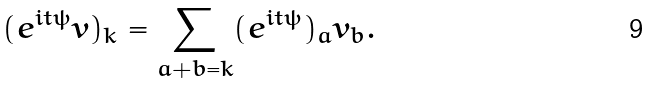Convert formula to latex. <formula><loc_0><loc_0><loc_500><loc_500>( e ^ { i t \psi } v ) _ { k } = \sum _ { a + b = k } ( e ^ { i t \psi } ) _ { a } v _ { b } .</formula> 